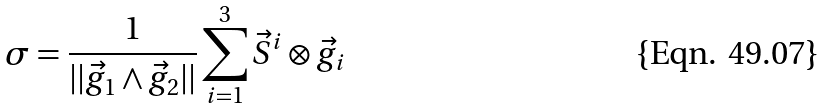<formula> <loc_0><loc_0><loc_500><loc_500>\sigma = \frac { 1 } { | | \vec { g } _ { 1 } \wedge \vec { g } _ { 2 } | | } \sum _ { i = 1 } ^ { 3 } \vec { S } ^ { i } \otimes \vec { g } _ { i }</formula> 